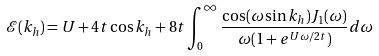<formula> <loc_0><loc_0><loc_500><loc_500>\mathcal { E } ( k _ { h } ) = U + 4 t \cos k _ { h } + 8 t \int _ { 0 } ^ { \infty } \frac { \cos ( \omega \sin k _ { h } ) J _ { 1 } ( \omega ) } { \omega ( 1 + e ^ { U \omega / 2 t } ) } d \omega</formula> 